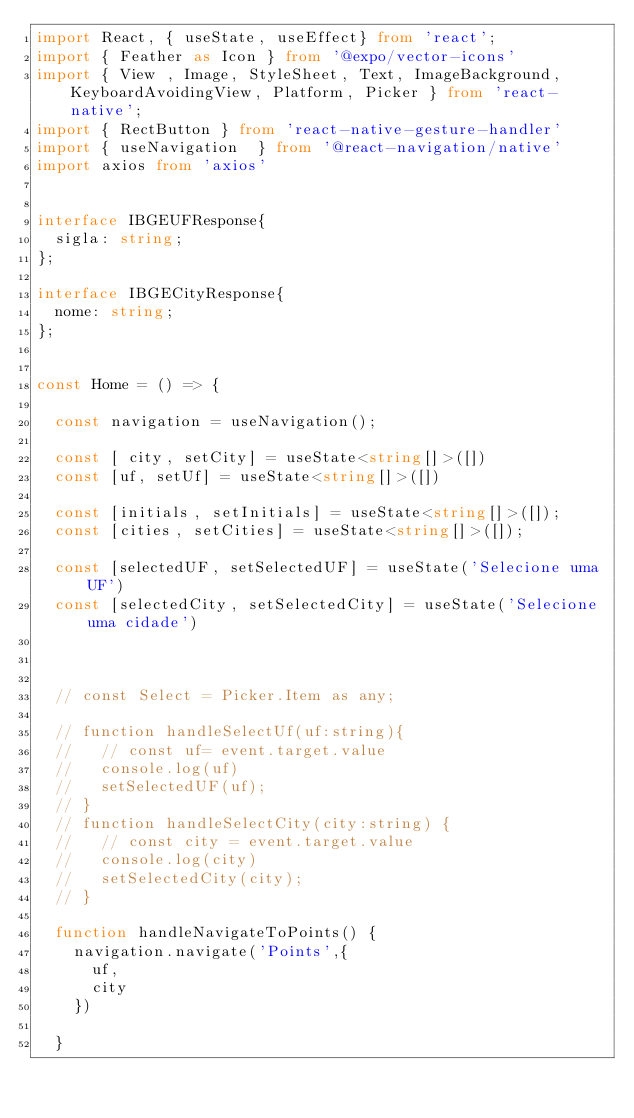Convert code to text. <code><loc_0><loc_0><loc_500><loc_500><_TypeScript_>import React, { useState, useEffect} from 'react';
import { Feather as Icon } from '@expo/vector-icons'
import { View , Image, StyleSheet, Text, ImageBackground,  KeyboardAvoidingView, Platform, Picker } from 'react-native';
import { RectButton } from 'react-native-gesture-handler'
import { useNavigation  } from '@react-navigation/native'
import axios from 'axios'


interface IBGEUFResponse{
  sigla: string;
};

interface IBGECityResponse{
  nome: string;
};


const Home = () => {

  const navigation = useNavigation();

  const [ city, setCity] = useState<string[]>([])
  const [uf, setUf] = useState<string[]>([])

  const [initials, setInitials] = useState<string[]>([]);
  const [cities, setCities] = useState<string[]>([]);

  const [selectedUF, setSelectedUF] = useState('Selecione uma UF')
  const [selectedCity, setSelectedCity] = useState('Selecione uma cidade')



  // const Select = Picker.Item as any;

  // function handleSelectUf(uf:string){
  //   // const uf= event.target.value
  //   console.log(uf)
  //   setSelectedUF(uf);
  // }
  // function handleSelectCity(city:string) {
  //   // const city = event.target.value
  //   console.log(city)
  //   setSelectedCity(city);
  // }

  function handleNavigateToPoints() {
    navigation.navigate('Points',{
      uf,
      city
    })
  
  }
  
</code> 